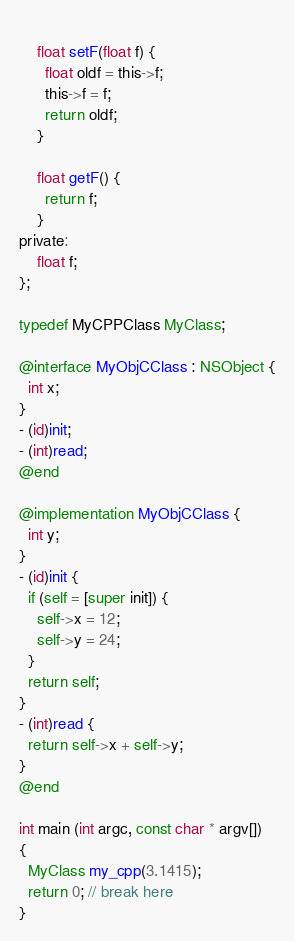<code> <loc_0><loc_0><loc_500><loc_500><_ObjectiveC_>    
    float setF(float f) {
      float oldf = this->f;
      this->f = f;
      return oldf;
    }
    
    float getF() {
      return f;
    }
private:
    float f;
};

typedef MyCPPClass MyClass;

@interface MyObjCClass : NSObject {
  int x;
}
- (id)init;
- (int)read;
@end

@implementation MyObjCClass {
  int y;
}
- (id)init {
  if (self = [super init]) {
    self->x = 12;
    self->y = 24;
  }
  return self;
}
- (int)read {
  return self->x + self->y;
}
@end

int main (int argc, const char * argv[])
{
  MyClass my_cpp(3.1415);
  return 0; // break here
}

</code> 